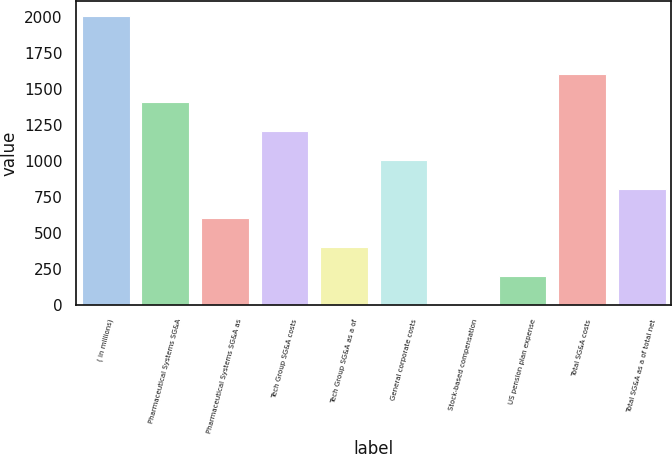Convert chart. <chart><loc_0><loc_0><loc_500><loc_500><bar_chart><fcel>( in millions)<fcel>Pharmaceutical Systems SG&A<fcel>Pharmaceutical Systems SG&A as<fcel>Tech Group SG&A costs<fcel>Tech Group SG&A as a of<fcel>General corporate costs<fcel>Stock-based compensation<fcel>US pension plan expense<fcel>Total SG&A costs<fcel>Total SG&A as a of total net<nl><fcel>2007<fcel>1406.43<fcel>605.67<fcel>1206.24<fcel>405.48<fcel>1006.05<fcel>5.1<fcel>205.29<fcel>1606.62<fcel>805.86<nl></chart> 